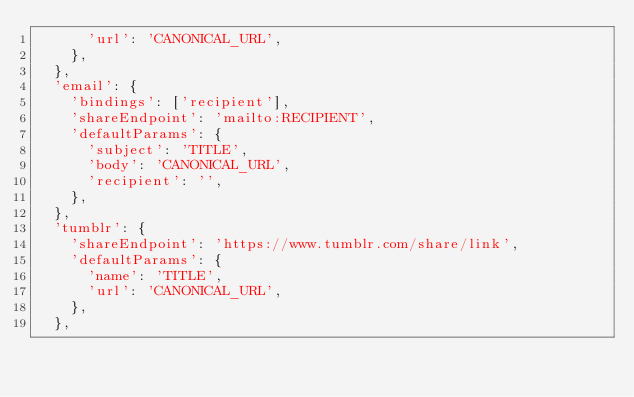Convert code to text. <code><loc_0><loc_0><loc_500><loc_500><_JavaScript_>      'url': 'CANONICAL_URL',
    },
  },
  'email': {
    'bindings': ['recipient'],
    'shareEndpoint': 'mailto:RECIPIENT',
    'defaultParams': {
      'subject': 'TITLE',
      'body': 'CANONICAL_URL',
      'recipient': '',
    },
  },
  'tumblr': {
    'shareEndpoint': 'https://www.tumblr.com/share/link',
    'defaultParams': {
      'name': 'TITLE',
      'url': 'CANONICAL_URL',
    },
  },</code> 